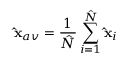Convert formula to latex. <formula><loc_0><loc_0><loc_500><loc_500>\hat { x } _ { a v } = \frac { 1 } { \hat { N } } \sum _ { i = 1 } ^ { \hat { N } } \hat { x } _ { i }</formula> 